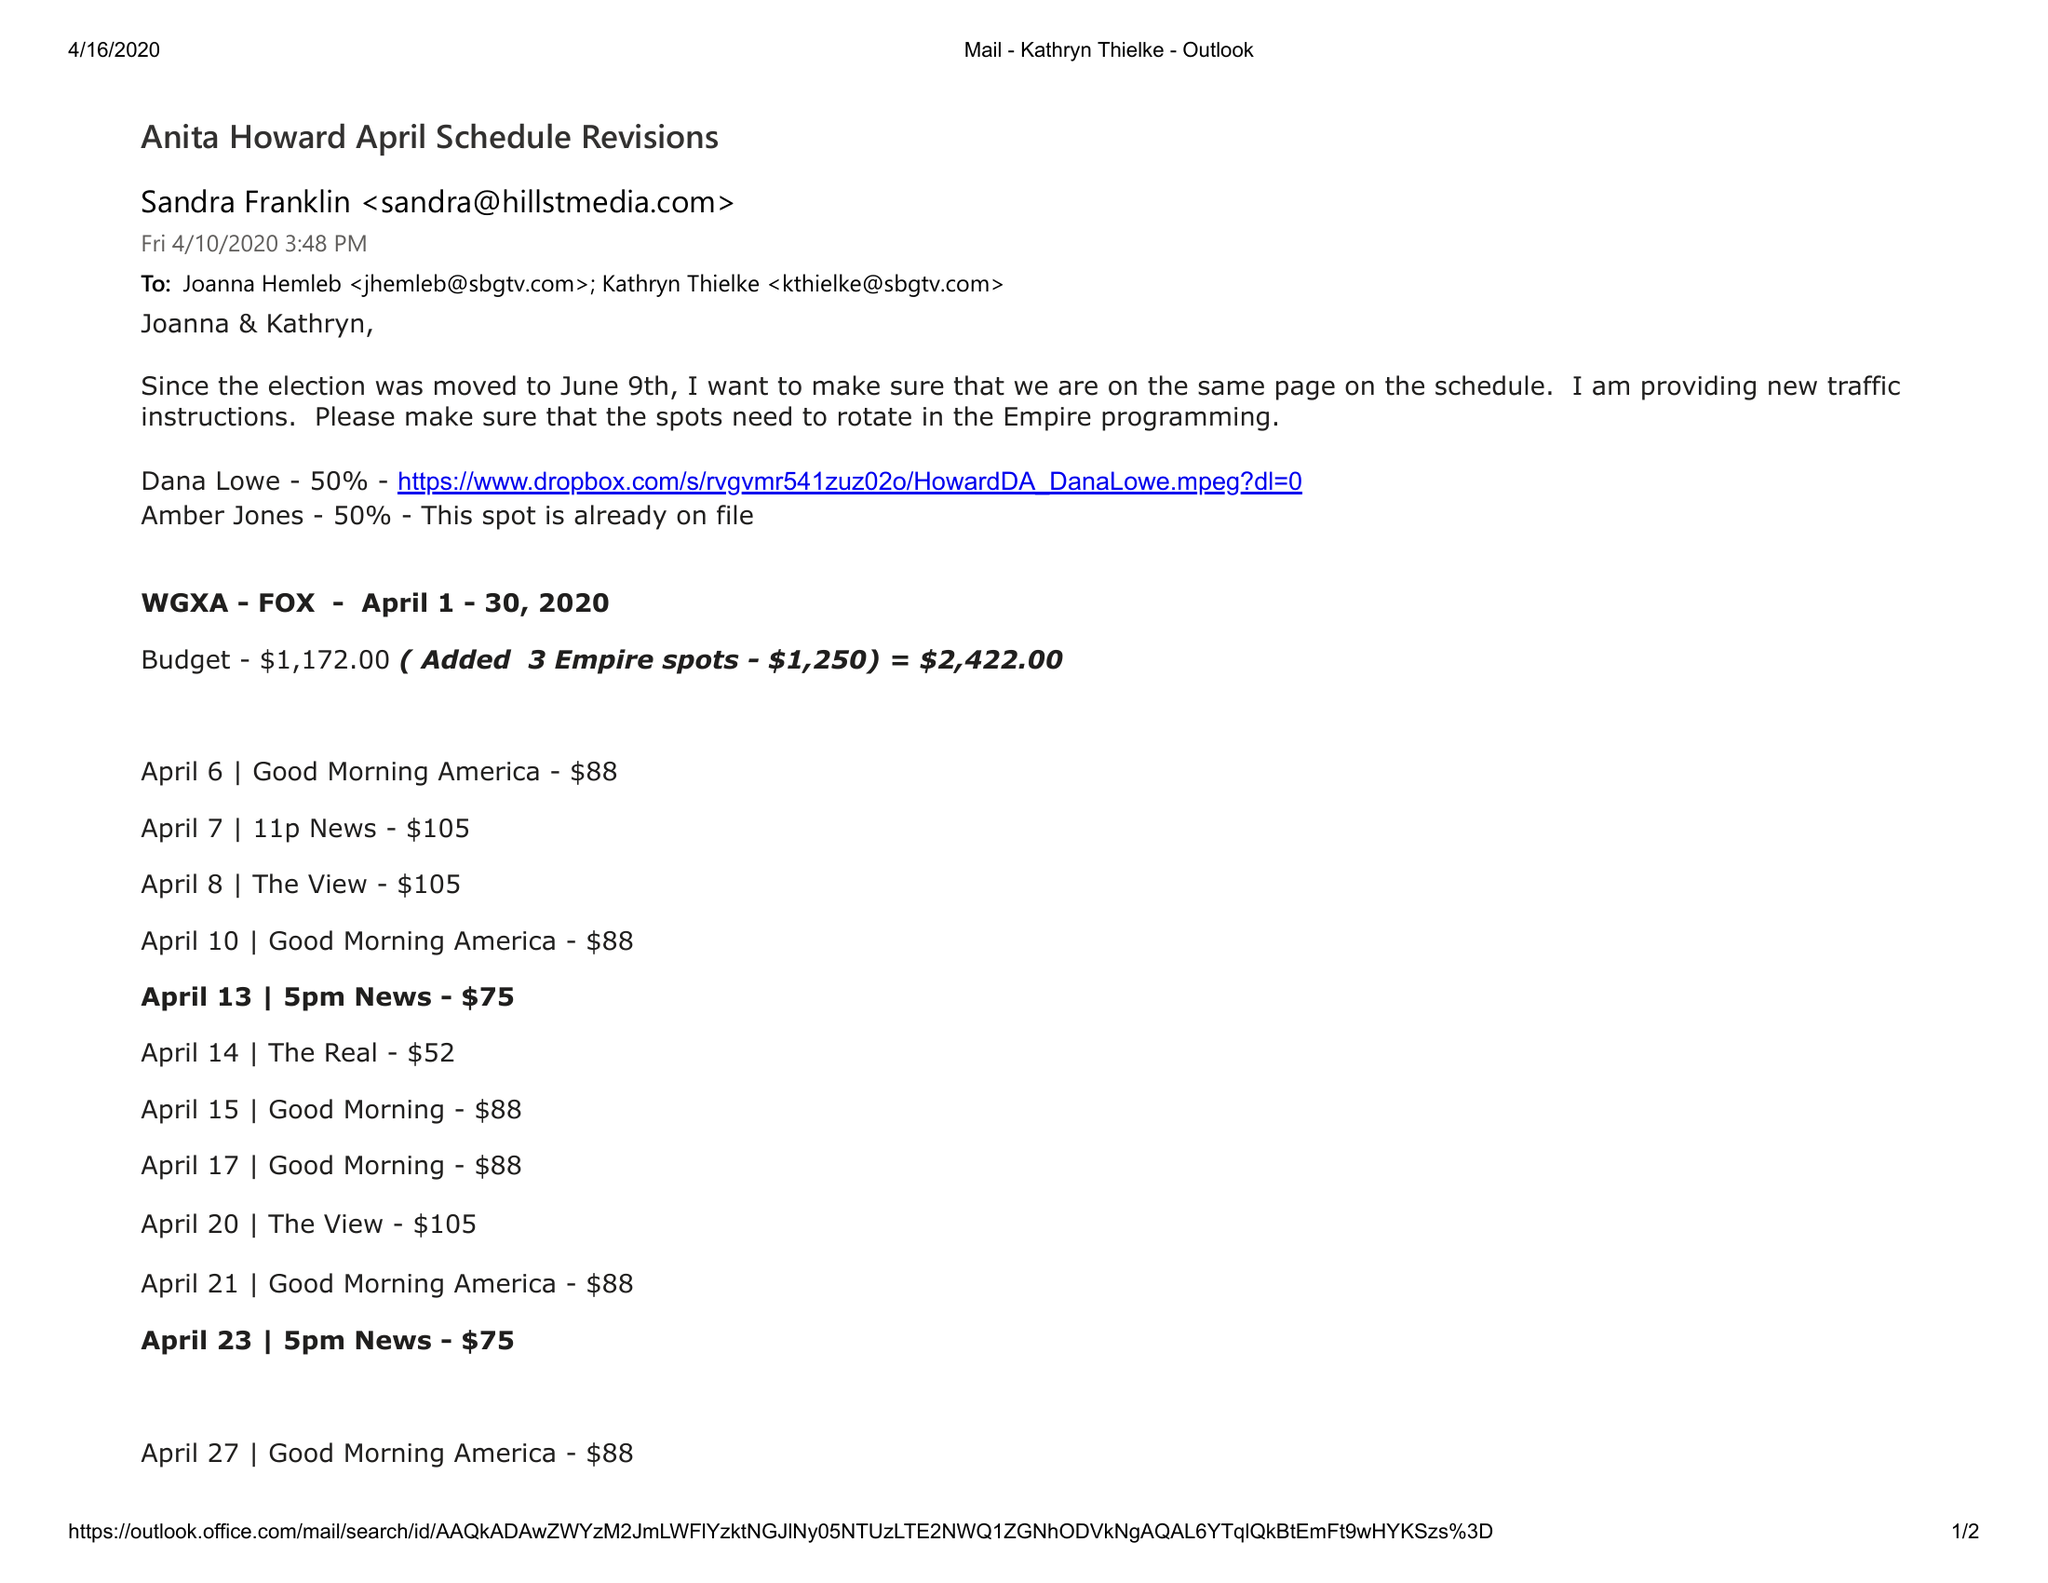What is the value for the contract_num?
Answer the question using a single word or phrase. None 